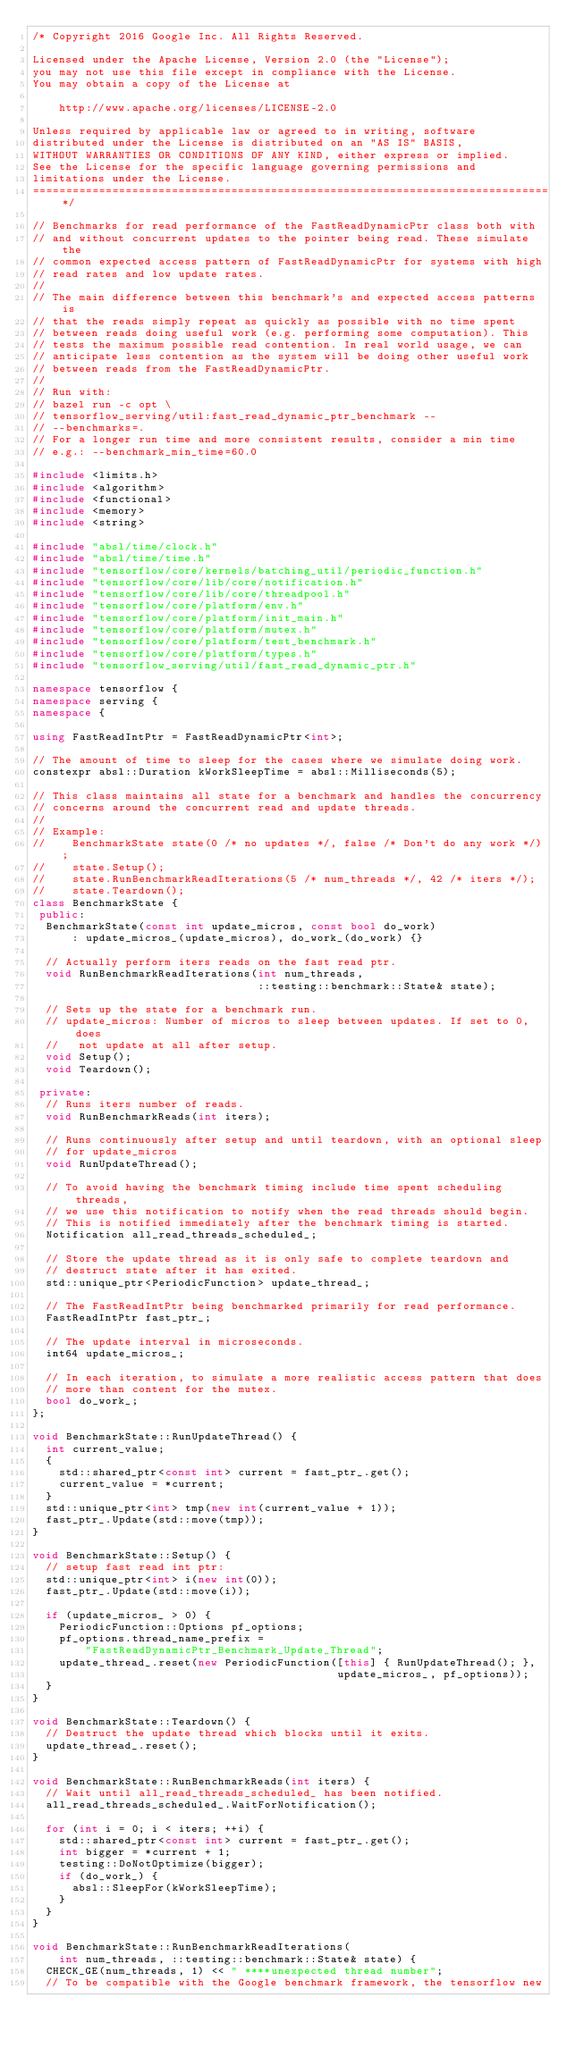Convert code to text. <code><loc_0><loc_0><loc_500><loc_500><_C++_>/* Copyright 2016 Google Inc. All Rights Reserved.

Licensed under the Apache License, Version 2.0 (the "License");
you may not use this file except in compliance with the License.
You may obtain a copy of the License at

    http://www.apache.org/licenses/LICENSE-2.0

Unless required by applicable law or agreed to in writing, software
distributed under the License is distributed on an "AS IS" BASIS,
WITHOUT WARRANTIES OR CONDITIONS OF ANY KIND, either express or implied.
See the License for the specific language governing permissions and
limitations under the License.
==============================================================================*/

// Benchmarks for read performance of the FastReadDynamicPtr class both with
// and without concurrent updates to the pointer being read. These simulate the
// common expected access pattern of FastReadDynamicPtr for systems with high
// read rates and low update rates.
//
// The main difference between this benchmark's and expected access patterns is
// that the reads simply repeat as quickly as possible with no time spent
// between reads doing useful work (e.g. performing some computation). This
// tests the maximum possible read contention. In real world usage, we can
// anticipate less contention as the system will be doing other useful work
// between reads from the FastReadDynamicPtr.
//
// Run with:
// bazel run -c opt \
// tensorflow_serving/util:fast_read_dynamic_ptr_benchmark --
// --benchmarks=.
// For a longer run time and more consistent results, consider a min time
// e.g.: --benchmark_min_time=60.0

#include <limits.h>
#include <algorithm>
#include <functional>
#include <memory>
#include <string>

#include "absl/time/clock.h"
#include "absl/time/time.h"
#include "tensorflow/core/kernels/batching_util/periodic_function.h"
#include "tensorflow/core/lib/core/notification.h"
#include "tensorflow/core/lib/core/threadpool.h"
#include "tensorflow/core/platform/env.h"
#include "tensorflow/core/platform/init_main.h"
#include "tensorflow/core/platform/mutex.h"
#include "tensorflow/core/platform/test_benchmark.h"
#include "tensorflow/core/platform/types.h"
#include "tensorflow_serving/util/fast_read_dynamic_ptr.h"

namespace tensorflow {
namespace serving {
namespace {

using FastReadIntPtr = FastReadDynamicPtr<int>;

// The amount of time to sleep for the cases where we simulate doing work.
constexpr absl::Duration kWorkSleepTime = absl::Milliseconds(5);

// This class maintains all state for a benchmark and handles the concurrency
// concerns around the concurrent read and update threads.
//
// Example:
//    BenchmarkState state(0 /* no updates */, false /* Don't do any work */);
//    state.Setup();
//    state.RunBenchmarkReadIterations(5 /* num_threads */, 42 /* iters */);
//    state.Teardown();
class BenchmarkState {
 public:
  BenchmarkState(const int update_micros, const bool do_work)
      : update_micros_(update_micros), do_work_(do_work) {}

  // Actually perform iters reads on the fast read ptr.
  void RunBenchmarkReadIterations(int num_threads,
                                  ::testing::benchmark::State& state);

  // Sets up the state for a benchmark run.
  // update_micros: Number of micros to sleep between updates. If set to 0, does
  //   not update at all after setup.
  void Setup();
  void Teardown();

 private:
  // Runs iters number of reads.
  void RunBenchmarkReads(int iters);

  // Runs continuously after setup and until teardown, with an optional sleep
  // for update_micros
  void RunUpdateThread();

  // To avoid having the benchmark timing include time spent scheduling threads,
  // we use this notification to notify when the read threads should begin.
  // This is notified immediately after the benchmark timing is started.
  Notification all_read_threads_scheduled_;

  // Store the update thread as it is only safe to complete teardown and
  // destruct state after it has exited.
  std::unique_ptr<PeriodicFunction> update_thread_;

  // The FastReadIntPtr being benchmarked primarily for read performance.
  FastReadIntPtr fast_ptr_;

  // The update interval in microseconds.
  int64 update_micros_;

  // In each iteration, to simulate a more realistic access pattern that does
  // more than content for the mutex.
  bool do_work_;
};

void BenchmarkState::RunUpdateThread() {
  int current_value;
  {
    std::shared_ptr<const int> current = fast_ptr_.get();
    current_value = *current;
  }
  std::unique_ptr<int> tmp(new int(current_value + 1));
  fast_ptr_.Update(std::move(tmp));
}

void BenchmarkState::Setup() {
  // setup fast read int ptr:
  std::unique_ptr<int> i(new int(0));
  fast_ptr_.Update(std::move(i));

  if (update_micros_ > 0) {
    PeriodicFunction::Options pf_options;
    pf_options.thread_name_prefix =
        "FastReadDynamicPtr_Benchmark_Update_Thread";
    update_thread_.reset(new PeriodicFunction([this] { RunUpdateThread(); },
                                              update_micros_, pf_options));
  }
}

void BenchmarkState::Teardown() {
  // Destruct the update thread which blocks until it exits.
  update_thread_.reset();
}

void BenchmarkState::RunBenchmarkReads(int iters) {
  // Wait until all_read_threads_scheduled_ has been notified.
  all_read_threads_scheduled_.WaitForNotification();

  for (int i = 0; i < iters; ++i) {
    std::shared_ptr<const int> current = fast_ptr_.get();
    int bigger = *current + 1;
    testing::DoNotOptimize(bigger);
    if (do_work_) {
      absl::SleepFor(kWorkSleepTime);
    }
  }
}

void BenchmarkState::RunBenchmarkReadIterations(
    int num_threads, ::testing::benchmark::State& state) {
  CHECK_GE(num_threads, 1) << " ****unexpected thread number";
  // To be compatible with the Google benchmark framework, the tensorflow new</code> 